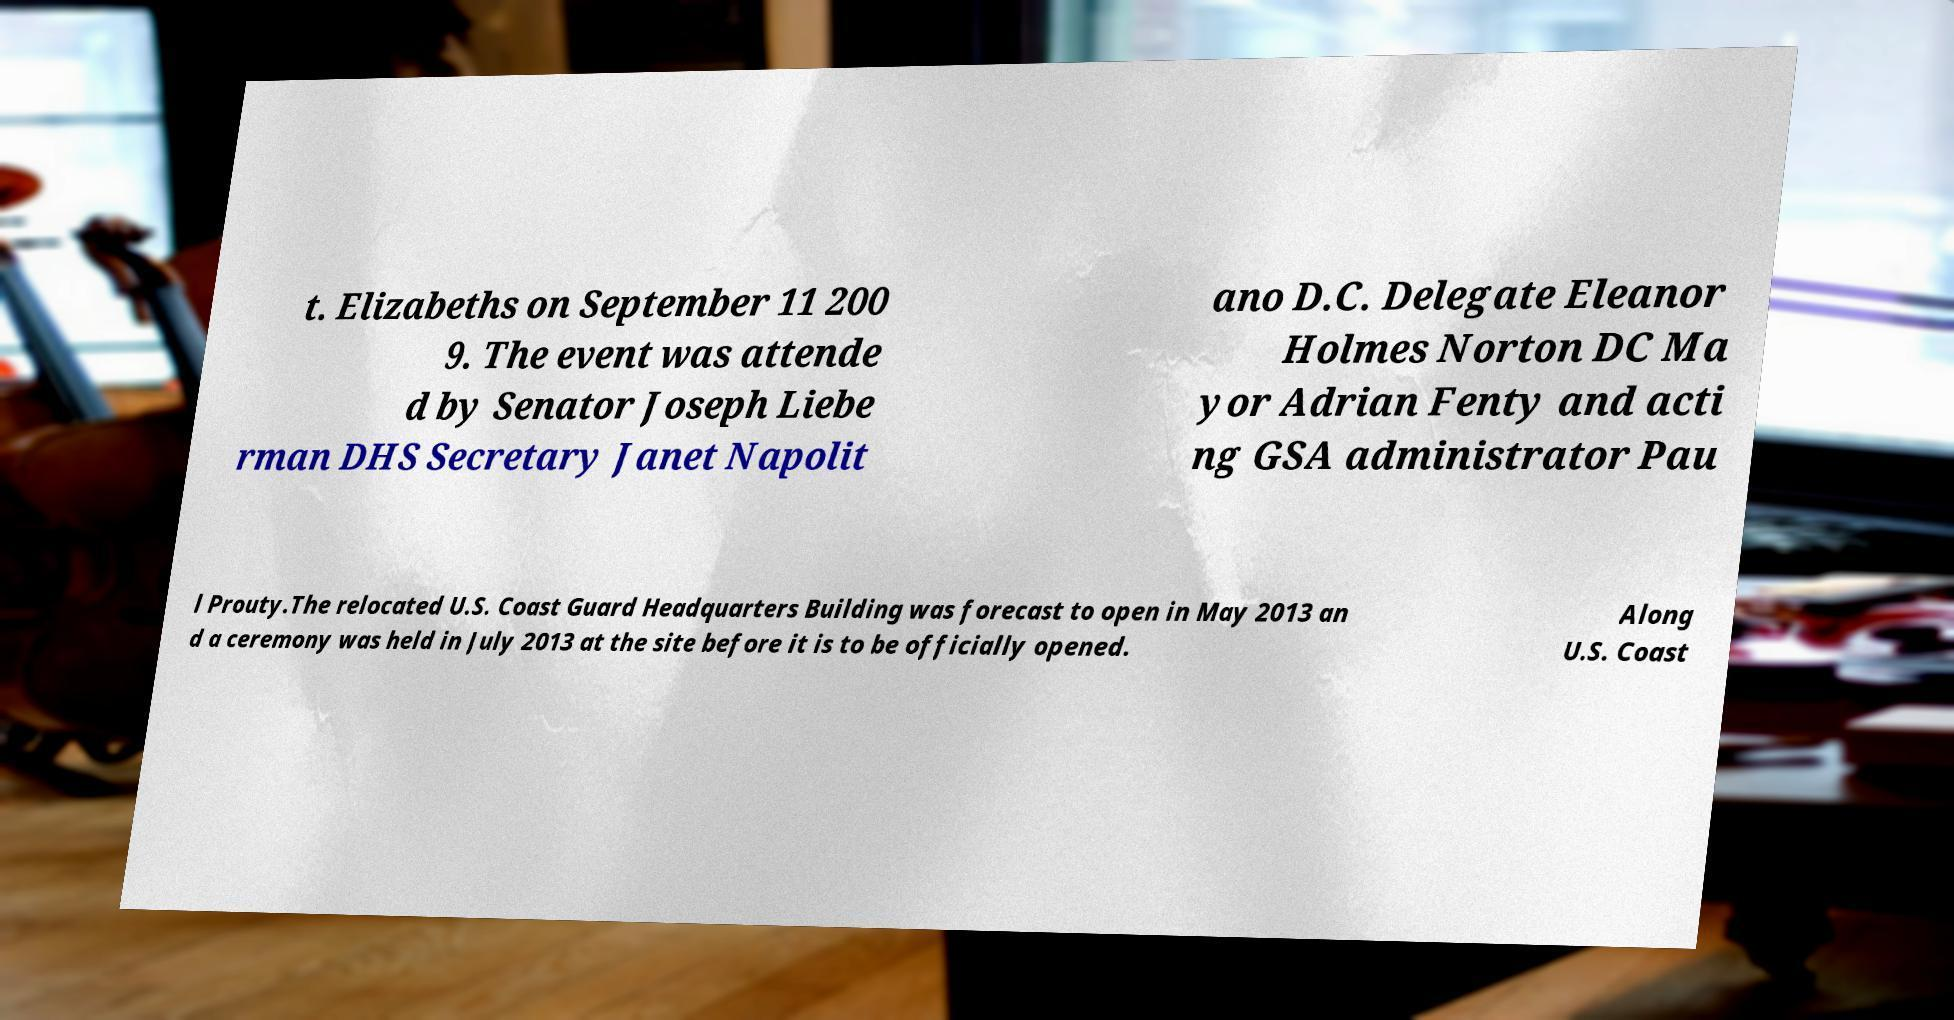I need the written content from this picture converted into text. Can you do that? t. Elizabeths on September 11 200 9. The event was attende d by Senator Joseph Liebe rman DHS Secretary Janet Napolit ano D.C. Delegate Eleanor Holmes Norton DC Ma yor Adrian Fenty and acti ng GSA administrator Pau l Prouty.The relocated U.S. Coast Guard Headquarters Building was forecast to open in May 2013 an d a ceremony was held in July 2013 at the site before it is to be officially opened. Along U.S. Coast 